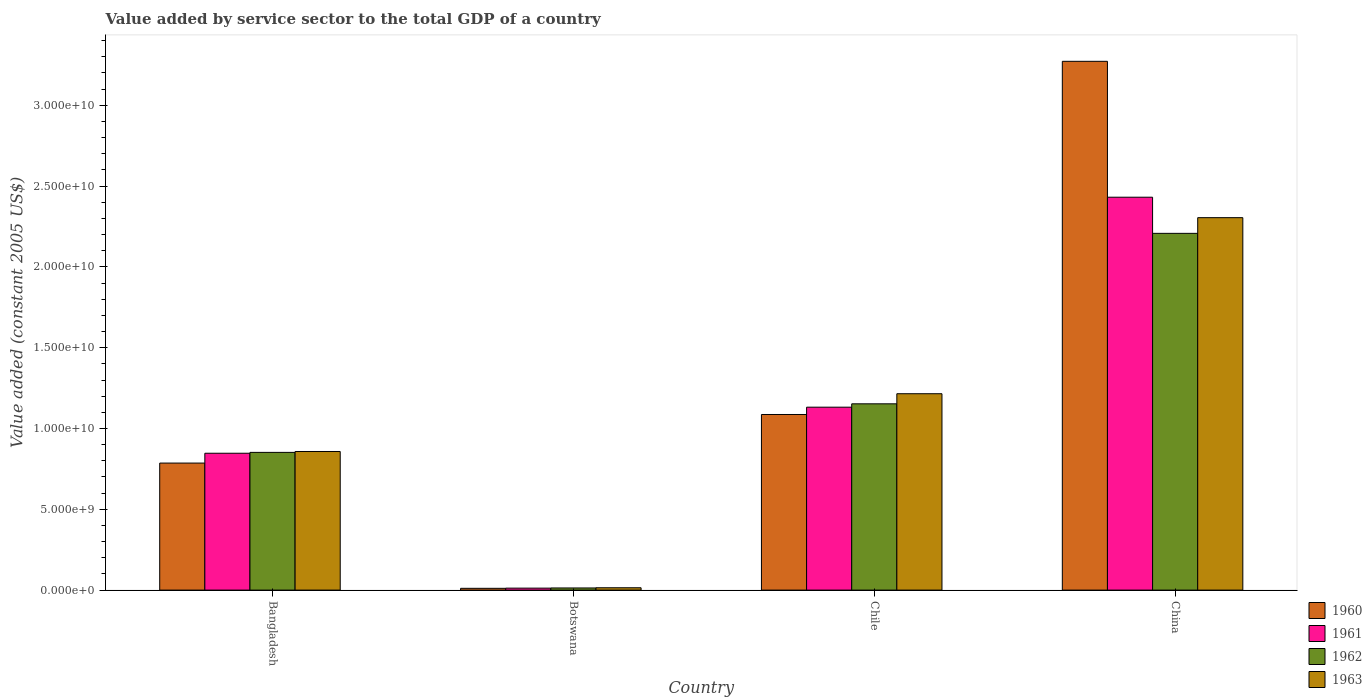Are the number of bars per tick equal to the number of legend labels?
Your answer should be compact. Yes. How many bars are there on the 2nd tick from the left?
Give a very brief answer. 4. How many bars are there on the 1st tick from the right?
Your answer should be very brief. 4. What is the label of the 3rd group of bars from the left?
Provide a short and direct response. Chile. In how many cases, is the number of bars for a given country not equal to the number of legend labels?
Ensure brevity in your answer.  0. What is the value added by service sector in 1963 in Chile?
Your answer should be very brief. 1.22e+1. Across all countries, what is the maximum value added by service sector in 1963?
Offer a very short reply. 2.30e+1. Across all countries, what is the minimum value added by service sector in 1960?
Offer a terse response. 1.11e+08. In which country was the value added by service sector in 1962 maximum?
Give a very brief answer. China. In which country was the value added by service sector in 1961 minimum?
Offer a terse response. Botswana. What is the total value added by service sector in 1962 in the graph?
Give a very brief answer. 4.23e+1. What is the difference between the value added by service sector in 1960 in Bangladesh and that in Botswana?
Your answer should be very brief. 7.75e+09. What is the difference between the value added by service sector in 1960 in Bangladesh and the value added by service sector in 1963 in Botswana?
Ensure brevity in your answer.  7.72e+09. What is the average value added by service sector in 1962 per country?
Offer a terse response. 1.06e+1. What is the difference between the value added by service sector of/in 1963 and value added by service sector of/in 1961 in Bangladesh?
Ensure brevity in your answer.  1.08e+08. In how many countries, is the value added by service sector in 1961 greater than 9000000000 US$?
Your answer should be very brief. 2. What is the ratio of the value added by service sector in 1963 in Botswana to that in Chile?
Keep it short and to the point. 0.01. Is the difference between the value added by service sector in 1963 in Bangladesh and Chile greater than the difference between the value added by service sector in 1961 in Bangladesh and Chile?
Keep it short and to the point. No. What is the difference between the highest and the second highest value added by service sector in 1960?
Your answer should be compact. -2.19e+1. What is the difference between the highest and the lowest value added by service sector in 1961?
Provide a short and direct response. 2.42e+1. In how many countries, is the value added by service sector in 1961 greater than the average value added by service sector in 1961 taken over all countries?
Offer a terse response. 2. Is it the case that in every country, the sum of the value added by service sector in 1960 and value added by service sector in 1963 is greater than the sum of value added by service sector in 1961 and value added by service sector in 1962?
Your response must be concise. No. What does the 4th bar from the left in China represents?
Offer a terse response. 1963. What does the 1st bar from the right in Botswana represents?
Your response must be concise. 1963. Is it the case that in every country, the sum of the value added by service sector in 1962 and value added by service sector in 1961 is greater than the value added by service sector in 1960?
Ensure brevity in your answer.  Yes. Are all the bars in the graph horizontal?
Provide a short and direct response. No. Does the graph contain grids?
Offer a very short reply. No. How many legend labels are there?
Your response must be concise. 4. How are the legend labels stacked?
Ensure brevity in your answer.  Vertical. What is the title of the graph?
Provide a succinct answer. Value added by service sector to the total GDP of a country. What is the label or title of the Y-axis?
Provide a succinct answer. Value added (constant 2005 US$). What is the Value added (constant 2005 US$) in 1960 in Bangladesh?
Provide a short and direct response. 7.86e+09. What is the Value added (constant 2005 US$) in 1961 in Bangladesh?
Your response must be concise. 8.47e+09. What is the Value added (constant 2005 US$) in 1962 in Bangladesh?
Your response must be concise. 8.52e+09. What is the Value added (constant 2005 US$) of 1963 in Bangladesh?
Your answer should be compact. 8.58e+09. What is the Value added (constant 2005 US$) of 1960 in Botswana?
Provide a succinct answer. 1.11e+08. What is the Value added (constant 2005 US$) in 1961 in Botswana?
Offer a terse response. 1.22e+08. What is the Value added (constant 2005 US$) in 1962 in Botswana?
Ensure brevity in your answer.  1.32e+08. What is the Value added (constant 2005 US$) of 1963 in Botswana?
Your answer should be compact. 1.45e+08. What is the Value added (constant 2005 US$) of 1960 in Chile?
Ensure brevity in your answer.  1.09e+1. What is the Value added (constant 2005 US$) of 1961 in Chile?
Your answer should be compact. 1.13e+1. What is the Value added (constant 2005 US$) in 1962 in Chile?
Offer a terse response. 1.15e+1. What is the Value added (constant 2005 US$) in 1963 in Chile?
Provide a succinct answer. 1.22e+1. What is the Value added (constant 2005 US$) in 1960 in China?
Provide a succinct answer. 3.27e+1. What is the Value added (constant 2005 US$) in 1961 in China?
Offer a very short reply. 2.43e+1. What is the Value added (constant 2005 US$) in 1962 in China?
Keep it short and to the point. 2.21e+1. What is the Value added (constant 2005 US$) in 1963 in China?
Your response must be concise. 2.30e+1. Across all countries, what is the maximum Value added (constant 2005 US$) in 1960?
Offer a very short reply. 3.27e+1. Across all countries, what is the maximum Value added (constant 2005 US$) of 1961?
Make the answer very short. 2.43e+1. Across all countries, what is the maximum Value added (constant 2005 US$) of 1962?
Make the answer very short. 2.21e+1. Across all countries, what is the maximum Value added (constant 2005 US$) of 1963?
Offer a terse response. 2.30e+1. Across all countries, what is the minimum Value added (constant 2005 US$) in 1960?
Keep it short and to the point. 1.11e+08. Across all countries, what is the minimum Value added (constant 2005 US$) in 1961?
Make the answer very short. 1.22e+08. Across all countries, what is the minimum Value added (constant 2005 US$) of 1962?
Make the answer very short. 1.32e+08. Across all countries, what is the minimum Value added (constant 2005 US$) of 1963?
Ensure brevity in your answer.  1.45e+08. What is the total Value added (constant 2005 US$) of 1960 in the graph?
Provide a succinct answer. 5.16e+1. What is the total Value added (constant 2005 US$) of 1961 in the graph?
Provide a succinct answer. 4.42e+1. What is the total Value added (constant 2005 US$) of 1962 in the graph?
Offer a very short reply. 4.23e+1. What is the total Value added (constant 2005 US$) of 1963 in the graph?
Make the answer very short. 4.39e+1. What is the difference between the Value added (constant 2005 US$) in 1960 in Bangladesh and that in Botswana?
Make the answer very short. 7.75e+09. What is the difference between the Value added (constant 2005 US$) in 1961 in Bangladesh and that in Botswana?
Offer a very short reply. 8.35e+09. What is the difference between the Value added (constant 2005 US$) of 1962 in Bangladesh and that in Botswana?
Your answer should be very brief. 8.39e+09. What is the difference between the Value added (constant 2005 US$) of 1963 in Bangladesh and that in Botswana?
Your answer should be compact. 8.43e+09. What is the difference between the Value added (constant 2005 US$) in 1960 in Bangladesh and that in Chile?
Provide a succinct answer. -3.01e+09. What is the difference between the Value added (constant 2005 US$) of 1961 in Bangladesh and that in Chile?
Provide a succinct answer. -2.85e+09. What is the difference between the Value added (constant 2005 US$) of 1962 in Bangladesh and that in Chile?
Your answer should be compact. -3.00e+09. What is the difference between the Value added (constant 2005 US$) in 1963 in Bangladesh and that in Chile?
Offer a terse response. -3.58e+09. What is the difference between the Value added (constant 2005 US$) of 1960 in Bangladesh and that in China?
Your answer should be very brief. -2.49e+1. What is the difference between the Value added (constant 2005 US$) of 1961 in Bangladesh and that in China?
Make the answer very short. -1.58e+1. What is the difference between the Value added (constant 2005 US$) in 1962 in Bangladesh and that in China?
Provide a short and direct response. -1.36e+1. What is the difference between the Value added (constant 2005 US$) in 1963 in Bangladesh and that in China?
Your response must be concise. -1.45e+1. What is the difference between the Value added (constant 2005 US$) of 1960 in Botswana and that in Chile?
Ensure brevity in your answer.  -1.08e+1. What is the difference between the Value added (constant 2005 US$) in 1961 in Botswana and that in Chile?
Your answer should be compact. -1.12e+1. What is the difference between the Value added (constant 2005 US$) of 1962 in Botswana and that in Chile?
Ensure brevity in your answer.  -1.14e+1. What is the difference between the Value added (constant 2005 US$) in 1963 in Botswana and that in Chile?
Keep it short and to the point. -1.20e+1. What is the difference between the Value added (constant 2005 US$) of 1960 in Botswana and that in China?
Your answer should be very brief. -3.26e+1. What is the difference between the Value added (constant 2005 US$) of 1961 in Botswana and that in China?
Provide a short and direct response. -2.42e+1. What is the difference between the Value added (constant 2005 US$) of 1962 in Botswana and that in China?
Your answer should be very brief. -2.19e+1. What is the difference between the Value added (constant 2005 US$) of 1963 in Botswana and that in China?
Offer a terse response. -2.29e+1. What is the difference between the Value added (constant 2005 US$) of 1960 in Chile and that in China?
Provide a short and direct response. -2.19e+1. What is the difference between the Value added (constant 2005 US$) of 1961 in Chile and that in China?
Make the answer very short. -1.30e+1. What is the difference between the Value added (constant 2005 US$) of 1962 in Chile and that in China?
Provide a succinct answer. -1.05e+1. What is the difference between the Value added (constant 2005 US$) in 1963 in Chile and that in China?
Offer a terse response. -1.09e+1. What is the difference between the Value added (constant 2005 US$) in 1960 in Bangladesh and the Value added (constant 2005 US$) in 1961 in Botswana?
Your answer should be compact. 7.74e+09. What is the difference between the Value added (constant 2005 US$) of 1960 in Bangladesh and the Value added (constant 2005 US$) of 1962 in Botswana?
Your response must be concise. 7.73e+09. What is the difference between the Value added (constant 2005 US$) of 1960 in Bangladesh and the Value added (constant 2005 US$) of 1963 in Botswana?
Make the answer very short. 7.72e+09. What is the difference between the Value added (constant 2005 US$) of 1961 in Bangladesh and the Value added (constant 2005 US$) of 1962 in Botswana?
Keep it short and to the point. 8.34e+09. What is the difference between the Value added (constant 2005 US$) of 1961 in Bangladesh and the Value added (constant 2005 US$) of 1963 in Botswana?
Your response must be concise. 8.32e+09. What is the difference between the Value added (constant 2005 US$) of 1962 in Bangladesh and the Value added (constant 2005 US$) of 1963 in Botswana?
Your answer should be compact. 8.38e+09. What is the difference between the Value added (constant 2005 US$) in 1960 in Bangladesh and the Value added (constant 2005 US$) in 1961 in Chile?
Keep it short and to the point. -3.46e+09. What is the difference between the Value added (constant 2005 US$) in 1960 in Bangladesh and the Value added (constant 2005 US$) in 1962 in Chile?
Offer a very short reply. -3.67e+09. What is the difference between the Value added (constant 2005 US$) in 1960 in Bangladesh and the Value added (constant 2005 US$) in 1963 in Chile?
Give a very brief answer. -4.29e+09. What is the difference between the Value added (constant 2005 US$) of 1961 in Bangladesh and the Value added (constant 2005 US$) of 1962 in Chile?
Make the answer very short. -3.06e+09. What is the difference between the Value added (constant 2005 US$) in 1961 in Bangladesh and the Value added (constant 2005 US$) in 1963 in Chile?
Ensure brevity in your answer.  -3.68e+09. What is the difference between the Value added (constant 2005 US$) of 1962 in Bangladesh and the Value added (constant 2005 US$) of 1963 in Chile?
Provide a short and direct response. -3.63e+09. What is the difference between the Value added (constant 2005 US$) in 1960 in Bangladesh and the Value added (constant 2005 US$) in 1961 in China?
Provide a short and direct response. -1.65e+1. What is the difference between the Value added (constant 2005 US$) of 1960 in Bangladesh and the Value added (constant 2005 US$) of 1962 in China?
Your response must be concise. -1.42e+1. What is the difference between the Value added (constant 2005 US$) in 1960 in Bangladesh and the Value added (constant 2005 US$) in 1963 in China?
Offer a very short reply. -1.52e+1. What is the difference between the Value added (constant 2005 US$) of 1961 in Bangladesh and the Value added (constant 2005 US$) of 1962 in China?
Your answer should be very brief. -1.36e+1. What is the difference between the Value added (constant 2005 US$) in 1961 in Bangladesh and the Value added (constant 2005 US$) in 1963 in China?
Keep it short and to the point. -1.46e+1. What is the difference between the Value added (constant 2005 US$) in 1962 in Bangladesh and the Value added (constant 2005 US$) in 1963 in China?
Provide a short and direct response. -1.45e+1. What is the difference between the Value added (constant 2005 US$) in 1960 in Botswana and the Value added (constant 2005 US$) in 1961 in Chile?
Offer a very short reply. -1.12e+1. What is the difference between the Value added (constant 2005 US$) in 1960 in Botswana and the Value added (constant 2005 US$) in 1962 in Chile?
Keep it short and to the point. -1.14e+1. What is the difference between the Value added (constant 2005 US$) of 1960 in Botswana and the Value added (constant 2005 US$) of 1963 in Chile?
Your answer should be compact. -1.20e+1. What is the difference between the Value added (constant 2005 US$) of 1961 in Botswana and the Value added (constant 2005 US$) of 1962 in Chile?
Ensure brevity in your answer.  -1.14e+1. What is the difference between the Value added (constant 2005 US$) in 1961 in Botswana and the Value added (constant 2005 US$) in 1963 in Chile?
Offer a terse response. -1.20e+1. What is the difference between the Value added (constant 2005 US$) of 1962 in Botswana and the Value added (constant 2005 US$) of 1963 in Chile?
Offer a terse response. -1.20e+1. What is the difference between the Value added (constant 2005 US$) in 1960 in Botswana and the Value added (constant 2005 US$) in 1961 in China?
Keep it short and to the point. -2.42e+1. What is the difference between the Value added (constant 2005 US$) in 1960 in Botswana and the Value added (constant 2005 US$) in 1962 in China?
Make the answer very short. -2.20e+1. What is the difference between the Value added (constant 2005 US$) of 1960 in Botswana and the Value added (constant 2005 US$) of 1963 in China?
Offer a terse response. -2.29e+1. What is the difference between the Value added (constant 2005 US$) of 1961 in Botswana and the Value added (constant 2005 US$) of 1962 in China?
Offer a terse response. -2.20e+1. What is the difference between the Value added (constant 2005 US$) in 1961 in Botswana and the Value added (constant 2005 US$) in 1963 in China?
Make the answer very short. -2.29e+1. What is the difference between the Value added (constant 2005 US$) in 1962 in Botswana and the Value added (constant 2005 US$) in 1963 in China?
Keep it short and to the point. -2.29e+1. What is the difference between the Value added (constant 2005 US$) in 1960 in Chile and the Value added (constant 2005 US$) in 1961 in China?
Offer a terse response. -1.34e+1. What is the difference between the Value added (constant 2005 US$) in 1960 in Chile and the Value added (constant 2005 US$) in 1962 in China?
Make the answer very short. -1.12e+1. What is the difference between the Value added (constant 2005 US$) of 1960 in Chile and the Value added (constant 2005 US$) of 1963 in China?
Your response must be concise. -1.22e+1. What is the difference between the Value added (constant 2005 US$) of 1961 in Chile and the Value added (constant 2005 US$) of 1962 in China?
Your answer should be very brief. -1.08e+1. What is the difference between the Value added (constant 2005 US$) of 1961 in Chile and the Value added (constant 2005 US$) of 1963 in China?
Provide a short and direct response. -1.17e+1. What is the difference between the Value added (constant 2005 US$) in 1962 in Chile and the Value added (constant 2005 US$) in 1963 in China?
Give a very brief answer. -1.15e+1. What is the average Value added (constant 2005 US$) in 1960 per country?
Provide a short and direct response. 1.29e+1. What is the average Value added (constant 2005 US$) in 1961 per country?
Keep it short and to the point. 1.11e+1. What is the average Value added (constant 2005 US$) in 1962 per country?
Provide a succinct answer. 1.06e+1. What is the average Value added (constant 2005 US$) in 1963 per country?
Offer a terse response. 1.10e+1. What is the difference between the Value added (constant 2005 US$) in 1960 and Value added (constant 2005 US$) in 1961 in Bangladesh?
Offer a very short reply. -6.09e+08. What is the difference between the Value added (constant 2005 US$) in 1960 and Value added (constant 2005 US$) in 1962 in Bangladesh?
Provide a short and direct response. -6.62e+08. What is the difference between the Value added (constant 2005 US$) of 1960 and Value added (constant 2005 US$) of 1963 in Bangladesh?
Your answer should be compact. -7.16e+08. What is the difference between the Value added (constant 2005 US$) in 1961 and Value added (constant 2005 US$) in 1962 in Bangladesh?
Provide a succinct answer. -5.33e+07. What is the difference between the Value added (constant 2005 US$) of 1961 and Value added (constant 2005 US$) of 1963 in Bangladesh?
Provide a succinct answer. -1.08e+08. What is the difference between the Value added (constant 2005 US$) of 1962 and Value added (constant 2005 US$) of 1963 in Bangladesh?
Give a very brief answer. -5.45e+07. What is the difference between the Value added (constant 2005 US$) in 1960 and Value added (constant 2005 US$) in 1961 in Botswana?
Offer a terse response. -1.12e+07. What is the difference between the Value added (constant 2005 US$) in 1960 and Value added (constant 2005 US$) in 1962 in Botswana?
Your response must be concise. -2.17e+07. What is the difference between the Value added (constant 2005 US$) of 1960 and Value added (constant 2005 US$) of 1963 in Botswana?
Your answer should be very brief. -3.45e+07. What is the difference between the Value added (constant 2005 US$) in 1961 and Value added (constant 2005 US$) in 1962 in Botswana?
Your answer should be very brief. -1.05e+07. What is the difference between the Value added (constant 2005 US$) of 1961 and Value added (constant 2005 US$) of 1963 in Botswana?
Ensure brevity in your answer.  -2.33e+07. What is the difference between the Value added (constant 2005 US$) of 1962 and Value added (constant 2005 US$) of 1963 in Botswana?
Your response must be concise. -1.28e+07. What is the difference between the Value added (constant 2005 US$) in 1960 and Value added (constant 2005 US$) in 1961 in Chile?
Give a very brief answer. -4.53e+08. What is the difference between the Value added (constant 2005 US$) of 1960 and Value added (constant 2005 US$) of 1962 in Chile?
Your answer should be very brief. -6.60e+08. What is the difference between the Value added (constant 2005 US$) of 1960 and Value added (constant 2005 US$) of 1963 in Chile?
Ensure brevity in your answer.  -1.29e+09. What is the difference between the Value added (constant 2005 US$) in 1961 and Value added (constant 2005 US$) in 1962 in Chile?
Your response must be concise. -2.07e+08. What is the difference between the Value added (constant 2005 US$) of 1961 and Value added (constant 2005 US$) of 1963 in Chile?
Ensure brevity in your answer.  -8.32e+08. What is the difference between the Value added (constant 2005 US$) in 1962 and Value added (constant 2005 US$) in 1963 in Chile?
Ensure brevity in your answer.  -6.25e+08. What is the difference between the Value added (constant 2005 US$) of 1960 and Value added (constant 2005 US$) of 1961 in China?
Your response must be concise. 8.41e+09. What is the difference between the Value added (constant 2005 US$) in 1960 and Value added (constant 2005 US$) in 1962 in China?
Keep it short and to the point. 1.06e+1. What is the difference between the Value added (constant 2005 US$) in 1960 and Value added (constant 2005 US$) in 1963 in China?
Keep it short and to the point. 9.68e+09. What is the difference between the Value added (constant 2005 US$) in 1961 and Value added (constant 2005 US$) in 1962 in China?
Offer a terse response. 2.24e+09. What is the difference between the Value added (constant 2005 US$) of 1961 and Value added (constant 2005 US$) of 1963 in China?
Ensure brevity in your answer.  1.27e+09. What is the difference between the Value added (constant 2005 US$) of 1962 and Value added (constant 2005 US$) of 1963 in China?
Make the answer very short. -9.71e+08. What is the ratio of the Value added (constant 2005 US$) in 1960 in Bangladesh to that in Botswana?
Ensure brevity in your answer.  71.09. What is the ratio of the Value added (constant 2005 US$) in 1961 in Bangladesh to that in Botswana?
Offer a terse response. 69.55. What is the ratio of the Value added (constant 2005 US$) in 1962 in Bangladesh to that in Botswana?
Ensure brevity in your answer.  64.43. What is the ratio of the Value added (constant 2005 US$) in 1963 in Bangladesh to that in Botswana?
Keep it short and to the point. 59.12. What is the ratio of the Value added (constant 2005 US$) in 1960 in Bangladesh to that in Chile?
Keep it short and to the point. 0.72. What is the ratio of the Value added (constant 2005 US$) in 1961 in Bangladesh to that in Chile?
Provide a succinct answer. 0.75. What is the ratio of the Value added (constant 2005 US$) of 1962 in Bangladesh to that in Chile?
Your answer should be compact. 0.74. What is the ratio of the Value added (constant 2005 US$) in 1963 in Bangladesh to that in Chile?
Offer a very short reply. 0.71. What is the ratio of the Value added (constant 2005 US$) of 1960 in Bangladesh to that in China?
Your response must be concise. 0.24. What is the ratio of the Value added (constant 2005 US$) of 1961 in Bangladesh to that in China?
Your answer should be very brief. 0.35. What is the ratio of the Value added (constant 2005 US$) in 1962 in Bangladesh to that in China?
Make the answer very short. 0.39. What is the ratio of the Value added (constant 2005 US$) of 1963 in Bangladesh to that in China?
Provide a succinct answer. 0.37. What is the ratio of the Value added (constant 2005 US$) in 1960 in Botswana to that in Chile?
Offer a terse response. 0.01. What is the ratio of the Value added (constant 2005 US$) in 1961 in Botswana to that in Chile?
Your answer should be very brief. 0.01. What is the ratio of the Value added (constant 2005 US$) in 1962 in Botswana to that in Chile?
Offer a very short reply. 0.01. What is the ratio of the Value added (constant 2005 US$) of 1963 in Botswana to that in Chile?
Your answer should be very brief. 0.01. What is the ratio of the Value added (constant 2005 US$) of 1960 in Botswana to that in China?
Your response must be concise. 0. What is the ratio of the Value added (constant 2005 US$) in 1961 in Botswana to that in China?
Offer a terse response. 0.01. What is the ratio of the Value added (constant 2005 US$) of 1962 in Botswana to that in China?
Make the answer very short. 0.01. What is the ratio of the Value added (constant 2005 US$) in 1963 in Botswana to that in China?
Provide a succinct answer. 0.01. What is the ratio of the Value added (constant 2005 US$) in 1960 in Chile to that in China?
Offer a very short reply. 0.33. What is the ratio of the Value added (constant 2005 US$) of 1961 in Chile to that in China?
Offer a very short reply. 0.47. What is the ratio of the Value added (constant 2005 US$) of 1962 in Chile to that in China?
Provide a succinct answer. 0.52. What is the ratio of the Value added (constant 2005 US$) of 1963 in Chile to that in China?
Offer a very short reply. 0.53. What is the difference between the highest and the second highest Value added (constant 2005 US$) of 1960?
Your answer should be very brief. 2.19e+1. What is the difference between the highest and the second highest Value added (constant 2005 US$) in 1961?
Keep it short and to the point. 1.30e+1. What is the difference between the highest and the second highest Value added (constant 2005 US$) in 1962?
Ensure brevity in your answer.  1.05e+1. What is the difference between the highest and the second highest Value added (constant 2005 US$) of 1963?
Offer a terse response. 1.09e+1. What is the difference between the highest and the lowest Value added (constant 2005 US$) of 1960?
Keep it short and to the point. 3.26e+1. What is the difference between the highest and the lowest Value added (constant 2005 US$) in 1961?
Ensure brevity in your answer.  2.42e+1. What is the difference between the highest and the lowest Value added (constant 2005 US$) of 1962?
Make the answer very short. 2.19e+1. What is the difference between the highest and the lowest Value added (constant 2005 US$) in 1963?
Give a very brief answer. 2.29e+1. 